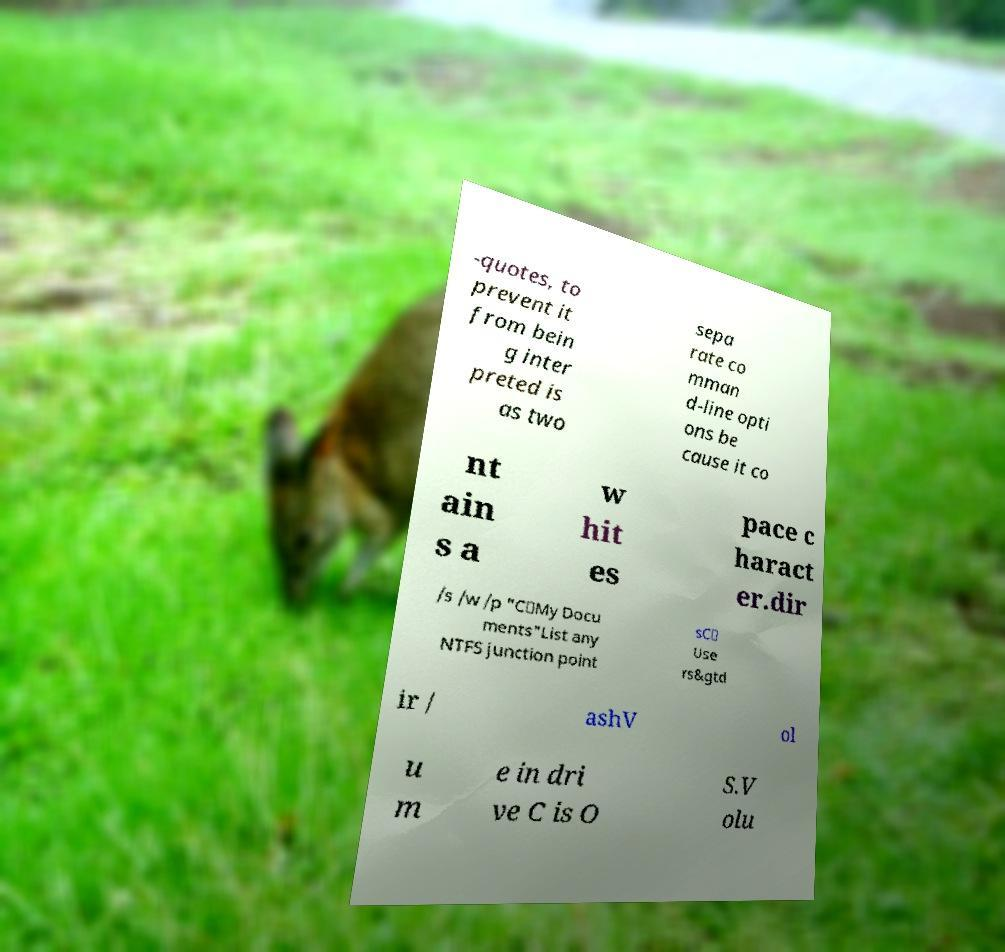Please identify and transcribe the text found in this image. -quotes, to prevent it from bein g inter preted is as two sepa rate co mman d-line opti ons be cause it co nt ain s a w hit es pace c haract er.dir /s /w /p "C\My Docu ments"List any NTFS junction point sC\ Use rs&gtd ir / ashV ol u m e in dri ve C is O S.V olu 